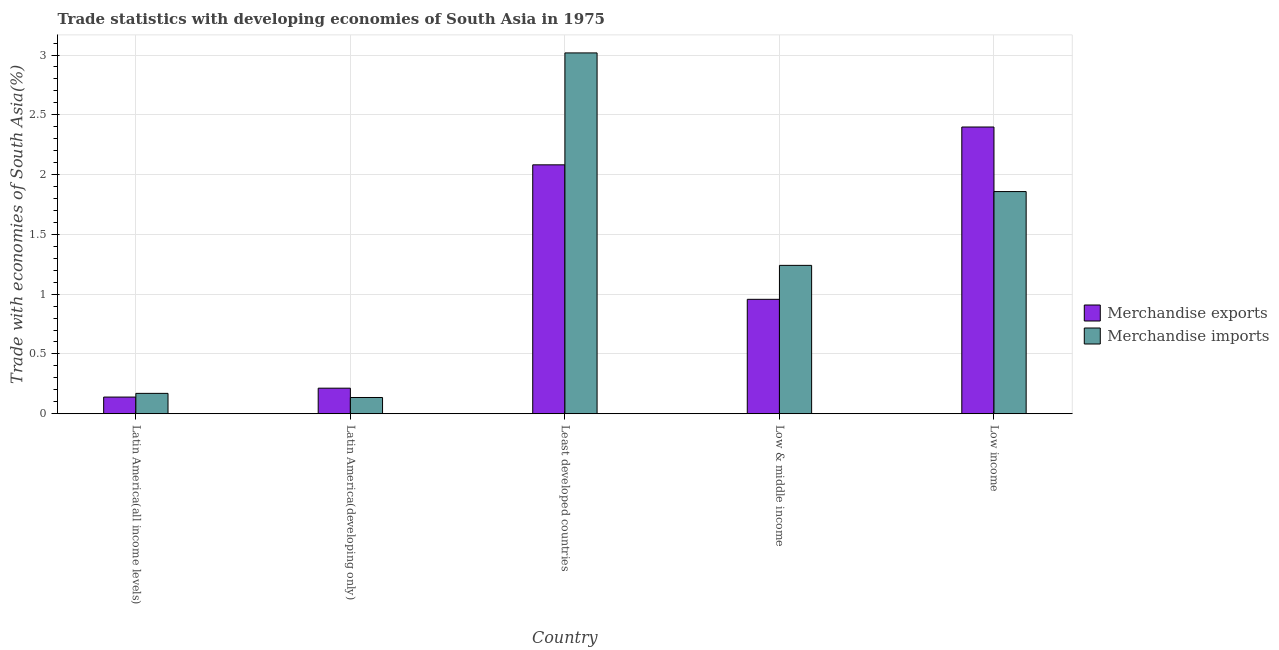Are the number of bars on each tick of the X-axis equal?
Give a very brief answer. Yes. How many bars are there on the 3rd tick from the right?
Your answer should be compact. 2. What is the label of the 3rd group of bars from the left?
Offer a terse response. Least developed countries. In how many cases, is the number of bars for a given country not equal to the number of legend labels?
Provide a short and direct response. 0. What is the merchandise exports in Least developed countries?
Your response must be concise. 2.08. Across all countries, what is the maximum merchandise imports?
Your response must be concise. 3.02. Across all countries, what is the minimum merchandise exports?
Your response must be concise. 0.14. In which country was the merchandise exports maximum?
Your response must be concise. Low income. In which country was the merchandise exports minimum?
Offer a very short reply. Latin America(all income levels). What is the total merchandise imports in the graph?
Your response must be concise. 6.42. What is the difference between the merchandise imports in Latin America(all income levels) and that in Latin America(developing only)?
Provide a short and direct response. 0.03. What is the difference between the merchandise imports in Low & middle income and the merchandise exports in Least developed countries?
Provide a short and direct response. -0.84. What is the average merchandise imports per country?
Give a very brief answer. 1.28. What is the difference between the merchandise imports and merchandise exports in Latin America(all income levels)?
Offer a very short reply. 0.03. In how many countries, is the merchandise exports greater than 2.8 %?
Your answer should be compact. 0. What is the ratio of the merchandise imports in Latin America(all income levels) to that in Least developed countries?
Your answer should be compact. 0.06. What is the difference between the highest and the second highest merchandise exports?
Offer a very short reply. 0.32. What is the difference between the highest and the lowest merchandise exports?
Your answer should be very brief. 2.26. Is the sum of the merchandise exports in Least developed countries and Low & middle income greater than the maximum merchandise imports across all countries?
Your answer should be compact. Yes. What does the 1st bar from the left in Low & middle income represents?
Offer a terse response. Merchandise exports. How many countries are there in the graph?
Make the answer very short. 5. What is the difference between two consecutive major ticks on the Y-axis?
Give a very brief answer. 0.5. Does the graph contain any zero values?
Your response must be concise. No. How many legend labels are there?
Provide a succinct answer. 2. What is the title of the graph?
Ensure brevity in your answer.  Trade statistics with developing economies of South Asia in 1975. Does "Diesel" appear as one of the legend labels in the graph?
Provide a short and direct response. No. What is the label or title of the X-axis?
Your response must be concise. Country. What is the label or title of the Y-axis?
Make the answer very short. Trade with economies of South Asia(%). What is the Trade with economies of South Asia(%) in Merchandise exports in Latin America(all income levels)?
Make the answer very short. 0.14. What is the Trade with economies of South Asia(%) of Merchandise imports in Latin America(all income levels)?
Offer a terse response. 0.17. What is the Trade with economies of South Asia(%) in Merchandise exports in Latin America(developing only)?
Your answer should be compact. 0.21. What is the Trade with economies of South Asia(%) in Merchandise imports in Latin America(developing only)?
Ensure brevity in your answer.  0.14. What is the Trade with economies of South Asia(%) of Merchandise exports in Least developed countries?
Your response must be concise. 2.08. What is the Trade with economies of South Asia(%) in Merchandise imports in Least developed countries?
Your answer should be compact. 3.02. What is the Trade with economies of South Asia(%) in Merchandise exports in Low & middle income?
Keep it short and to the point. 0.96. What is the Trade with economies of South Asia(%) of Merchandise imports in Low & middle income?
Offer a terse response. 1.24. What is the Trade with economies of South Asia(%) in Merchandise exports in Low income?
Provide a short and direct response. 2.4. What is the Trade with economies of South Asia(%) of Merchandise imports in Low income?
Your answer should be compact. 1.86. Across all countries, what is the maximum Trade with economies of South Asia(%) of Merchandise exports?
Provide a short and direct response. 2.4. Across all countries, what is the maximum Trade with economies of South Asia(%) in Merchandise imports?
Your response must be concise. 3.02. Across all countries, what is the minimum Trade with economies of South Asia(%) in Merchandise exports?
Your answer should be very brief. 0.14. Across all countries, what is the minimum Trade with economies of South Asia(%) in Merchandise imports?
Make the answer very short. 0.14. What is the total Trade with economies of South Asia(%) of Merchandise exports in the graph?
Your answer should be very brief. 5.79. What is the total Trade with economies of South Asia(%) of Merchandise imports in the graph?
Ensure brevity in your answer.  6.42. What is the difference between the Trade with economies of South Asia(%) in Merchandise exports in Latin America(all income levels) and that in Latin America(developing only)?
Provide a succinct answer. -0.07. What is the difference between the Trade with economies of South Asia(%) of Merchandise imports in Latin America(all income levels) and that in Latin America(developing only)?
Give a very brief answer. 0.03. What is the difference between the Trade with economies of South Asia(%) in Merchandise exports in Latin America(all income levels) and that in Least developed countries?
Make the answer very short. -1.94. What is the difference between the Trade with economies of South Asia(%) of Merchandise imports in Latin America(all income levels) and that in Least developed countries?
Ensure brevity in your answer.  -2.85. What is the difference between the Trade with economies of South Asia(%) in Merchandise exports in Latin America(all income levels) and that in Low & middle income?
Make the answer very short. -0.82. What is the difference between the Trade with economies of South Asia(%) in Merchandise imports in Latin America(all income levels) and that in Low & middle income?
Make the answer very short. -1.07. What is the difference between the Trade with economies of South Asia(%) of Merchandise exports in Latin America(all income levels) and that in Low income?
Ensure brevity in your answer.  -2.26. What is the difference between the Trade with economies of South Asia(%) of Merchandise imports in Latin America(all income levels) and that in Low income?
Ensure brevity in your answer.  -1.69. What is the difference between the Trade with economies of South Asia(%) in Merchandise exports in Latin America(developing only) and that in Least developed countries?
Offer a very short reply. -1.87. What is the difference between the Trade with economies of South Asia(%) in Merchandise imports in Latin America(developing only) and that in Least developed countries?
Your answer should be compact. -2.88. What is the difference between the Trade with economies of South Asia(%) in Merchandise exports in Latin America(developing only) and that in Low & middle income?
Keep it short and to the point. -0.74. What is the difference between the Trade with economies of South Asia(%) of Merchandise imports in Latin America(developing only) and that in Low & middle income?
Ensure brevity in your answer.  -1.11. What is the difference between the Trade with economies of South Asia(%) of Merchandise exports in Latin America(developing only) and that in Low income?
Provide a short and direct response. -2.18. What is the difference between the Trade with economies of South Asia(%) in Merchandise imports in Latin America(developing only) and that in Low income?
Make the answer very short. -1.72. What is the difference between the Trade with economies of South Asia(%) of Merchandise exports in Least developed countries and that in Low & middle income?
Keep it short and to the point. 1.12. What is the difference between the Trade with economies of South Asia(%) of Merchandise imports in Least developed countries and that in Low & middle income?
Ensure brevity in your answer.  1.78. What is the difference between the Trade with economies of South Asia(%) in Merchandise exports in Least developed countries and that in Low income?
Offer a very short reply. -0.32. What is the difference between the Trade with economies of South Asia(%) in Merchandise imports in Least developed countries and that in Low income?
Provide a short and direct response. 1.16. What is the difference between the Trade with economies of South Asia(%) in Merchandise exports in Low & middle income and that in Low income?
Provide a succinct answer. -1.44. What is the difference between the Trade with economies of South Asia(%) of Merchandise imports in Low & middle income and that in Low income?
Make the answer very short. -0.62. What is the difference between the Trade with economies of South Asia(%) of Merchandise exports in Latin America(all income levels) and the Trade with economies of South Asia(%) of Merchandise imports in Latin America(developing only)?
Your answer should be compact. 0. What is the difference between the Trade with economies of South Asia(%) of Merchandise exports in Latin America(all income levels) and the Trade with economies of South Asia(%) of Merchandise imports in Least developed countries?
Offer a terse response. -2.88. What is the difference between the Trade with economies of South Asia(%) of Merchandise exports in Latin America(all income levels) and the Trade with economies of South Asia(%) of Merchandise imports in Low & middle income?
Provide a short and direct response. -1.1. What is the difference between the Trade with economies of South Asia(%) in Merchandise exports in Latin America(all income levels) and the Trade with economies of South Asia(%) in Merchandise imports in Low income?
Provide a short and direct response. -1.72. What is the difference between the Trade with economies of South Asia(%) of Merchandise exports in Latin America(developing only) and the Trade with economies of South Asia(%) of Merchandise imports in Least developed countries?
Your response must be concise. -2.8. What is the difference between the Trade with economies of South Asia(%) in Merchandise exports in Latin America(developing only) and the Trade with economies of South Asia(%) in Merchandise imports in Low & middle income?
Give a very brief answer. -1.03. What is the difference between the Trade with economies of South Asia(%) in Merchandise exports in Latin America(developing only) and the Trade with economies of South Asia(%) in Merchandise imports in Low income?
Offer a very short reply. -1.64. What is the difference between the Trade with economies of South Asia(%) of Merchandise exports in Least developed countries and the Trade with economies of South Asia(%) of Merchandise imports in Low & middle income?
Offer a terse response. 0.84. What is the difference between the Trade with economies of South Asia(%) in Merchandise exports in Least developed countries and the Trade with economies of South Asia(%) in Merchandise imports in Low income?
Provide a short and direct response. 0.22. What is the difference between the Trade with economies of South Asia(%) in Merchandise exports in Low & middle income and the Trade with economies of South Asia(%) in Merchandise imports in Low income?
Your response must be concise. -0.9. What is the average Trade with economies of South Asia(%) of Merchandise exports per country?
Provide a succinct answer. 1.16. What is the average Trade with economies of South Asia(%) of Merchandise imports per country?
Provide a succinct answer. 1.28. What is the difference between the Trade with economies of South Asia(%) of Merchandise exports and Trade with economies of South Asia(%) of Merchandise imports in Latin America(all income levels)?
Your answer should be compact. -0.03. What is the difference between the Trade with economies of South Asia(%) of Merchandise exports and Trade with economies of South Asia(%) of Merchandise imports in Latin America(developing only)?
Provide a short and direct response. 0.08. What is the difference between the Trade with economies of South Asia(%) of Merchandise exports and Trade with economies of South Asia(%) of Merchandise imports in Least developed countries?
Provide a succinct answer. -0.94. What is the difference between the Trade with economies of South Asia(%) in Merchandise exports and Trade with economies of South Asia(%) in Merchandise imports in Low & middle income?
Make the answer very short. -0.28. What is the difference between the Trade with economies of South Asia(%) of Merchandise exports and Trade with economies of South Asia(%) of Merchandise imports in Low income?
Keep it short and to the point. 0.54. What is the ratio of the Trade with economies of South Asia(%) of Merchandise exports in Latin America(all income levels) to that in Latin America(developing only)?
Your answer should be compact. 0.65. What is the ratio of the Trade with economies of South Asia(%) of Merchandise imports in Latin America(all income levels) to that in Latin America(developing only)?
Your answer should be compact. 1.25. What is the ratio of the Trade with economies of South Asia(%) of Merchandise exports in Latin America(all income levels) to that in Least developed countries?
Your answer should be compact. 0.07. What is the ratio of the Trade with economies of South Asia(%) in Merchandise imports in Latin America(all income levels) to that in Least developed countries?
Your response must be concise. 0.06. What is the ratio of the Trade with economies of South Asia(%) of Merchandise exports in Latin America(all income levels) to that in Low & middle income?
Provide a succinct answer. 0.15. What is the ratio of the Trade with economies of South Asia(%) in Merchandise imports in Latin America(all income levels) to that in Low & middle income?
Give a very brief answer. 0.14. What is the ratio of the Trade with economies of South Asia(%) of Merchandise exports in Latin America(all income levels) to that in Low income?
Your answer should be compact. 0.06. What is the ratio of the Trade with economies of South Asia(%) of Merchandise imports in Latin America(all income levels) to that in Low income?
Give a very brief answer. 0.09. What is the ratio of the Trade with economies of South Asia(%) of Merchandise exports in Latin America(developing only) to that in Least developed countries?
Give a very brief answer. 0.1. What is the ratio of the Trade with economies of South Asia(%) of Merchandise imports in Latin America(developing only) to that in Least developed countries?
Give a very brief answer. 0.04. What is the ratio of the Trade with economies of South Asia(%) of Merchandise exports in Latin America(developing only) to that in Low & middle income?
Offer a terse response. 0.22. What is the ratio of the Trade with economies of South Asia(%) of Merchandise imports in Latin America(developing only) to that in Low & middle income?
Ensure brevity in your answer.  0.11. What is the ratio of the Trade with economies of South Asia(%) of Merchandise exports in Latin America(developing only) to that in Low income?
Your response must be concise. 0.09. What is the ratio of the Trade with economies of South Asia(%) in Merchandise imports in Latin America(developing only) to that in Low income?
Your response must be concise. 0.07. What is the ratio of the Trade with economies of South Asia(%) in Merchandise exports in Least developed countries to that in Low & middle income?
Offer a terse response. 2.18. What is the ratio of the Trade with economies of South Asia(%) in Merchandise imports in Least developed countries to that in Low & middle income?
Provide a short and direct response. 2.43. What is the ratio of the Trade with economies of South Asia(%) in Merchandise exports in Least developed countries to that in Low income?
Offer a terse response. 0.87. What is the ratio of the Trade with economies of South Asia(%) in Merchandise imports in Least developed countries to that in Low income?
Your answer should be compact. 1.62. What is the ratio of the Trade with economies of South Asia(%) of Merchandise exports in Low & middle income to that in Low income?
Make the answer very short. 0.4. What is the ratio of the Trade with economies of South Asia(%) in Merchandise imports in Low & middle income to that in Low income?
Ensure brevity in your answer.  0.67. What is the difference between the highest and the second highest Trade with economies of South Asia(%) in Merchandise exports?
Provide a short and direct response. 0.32. What is the difference between the highest and the second highest Trade with economies of South Asia(%) of Merchandise imports?
Your answer should be compact. 1.16. What is the difference between the highest and the lowest Trade with economies of South Asia(%) of Merchandise exports?
Your answer should be very brief. 2.26. What is the difference between the highest and the lowest Trade with economies of South Asia(%) in Merchandise imports?
Give a very brief answer. 2.88. 